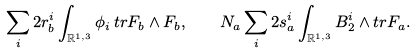Convert formula to latex. <formula><loc_0><loc_0><loc_500><loc_500>\sum _ { i } 2 r ^ { i } _ { b } \int _ { { \mathbb { R } } ^ { 1 , 3 } } \phi _ { i } \, t r F _ { b } \wedge F _ { b } , \quad N _ { a } \sum _ { i } 2 s ^ { i } _ { a } \int _ { { \mathbb { R } } ^ { 1 , 3 } } B ^ { i } _ { 2 } \wedge t r F _ { a } .</formula> 